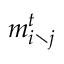<formula> <loc_0><loc_0><loc_500><loc_500>m _ { i \ j } ^ { t }</formula> 